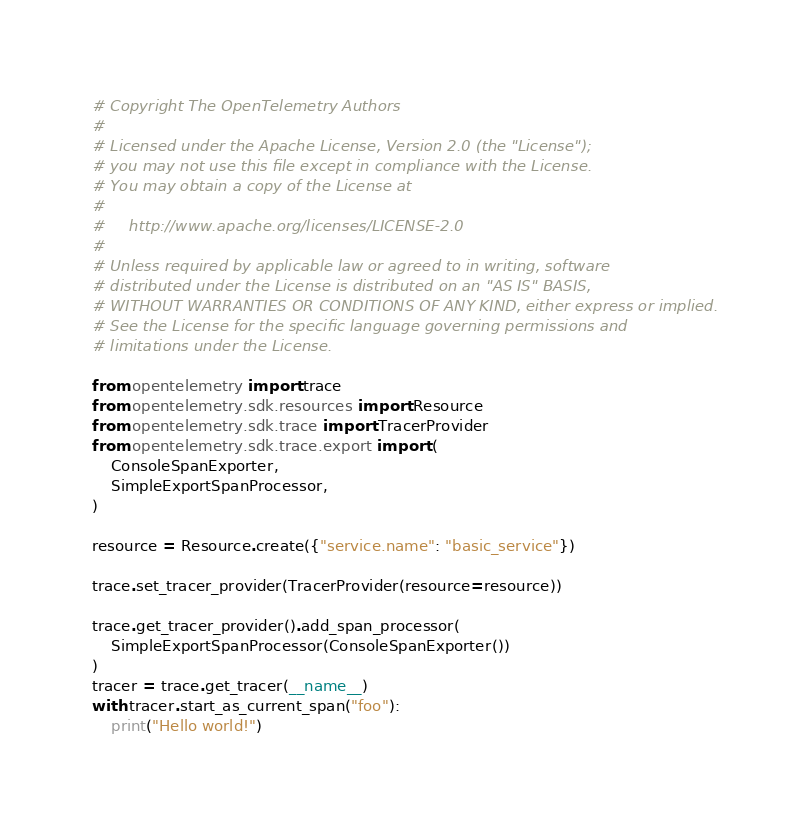<code> <loc_0><loc_0><loc_500><loc_500><_Python_># Copyright The OpenTelemetry Authors
#
# Licensed under the Apache License, Version 2.0 (the "License");
# you may not use this file except in compliance with the License.
# You may obtain a copy of the License at
#
#     http://www.apache.org/licenses/LICENSE-2.0
#
# Unless required by applicable law or agreed to in writing, software
# distributed under the License is distributed on an "AS IS" BASIS,
# WITHOUT WARRANTIES OR CONDITIONS OF ANY KIND, either express or implied.
# See the License for the specific language governing permissions and
# limitations under the License.

from opentelemetry import trace
from opentelemetry.sdk.resources import Resource
from opentelemetry.sdk.trace import TracerProvider
from opentelemetry.sdk.trace.export import (
    ConsoleSpanExporter,
    SimpleExportSpanProcessor,
)

resource = Resource.create({"service.name": "basic_service"})

trace.set_tracer_provider(TracerProvider(resource=resource))

trace.get_tracer_provider().add_span_processor(
    SimpleExportSpanProcessor(ConsoleSpanExporter())
)
tracer = trace.get_tracer(__name__)
with tracer.start_as_current_span("foo"):
    print("Hello world!")
</code> 